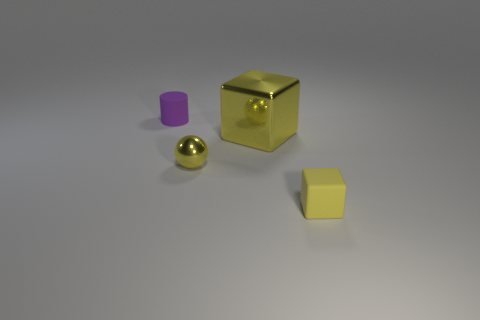The object in front of the small yellow shiny thing to the left of the yellow cube behind the yellow rubber cube is made of what material?
Offer a terse response. Rubber. There is a tiny rubber object that is in front of the small purple rubber object; is its shape the same as the big yellow metallic object?
Make the answer very short. Yes. What is the material of the cube right of the large object?
Your answer should be very brief. Rubber. What number of matte objects are tiny cubes or small cylinders?
Offer a very short reply. 2. Are there any shiny cubes of the same size as the yellow matte cube?
Keep it short and to the point. No. Is the number of small purple rubber cylinders in front of the purple rubber object greater than the number of matte blocks?
Offer a very short reply. No. How many tiny objects are rubber cubes or yellow shiny cylinders?
Provide a succinct answer. 1. What number of other purple objects are the same shape as the big thing?
Offer a terse response. 0. What is the material of the yellow cube behind the rubber object in front of the sphere?
Provide a short and direct response. Metal. How big is the matte thing that is in front of the purple cylinder?
Make the answer very short. Small. 